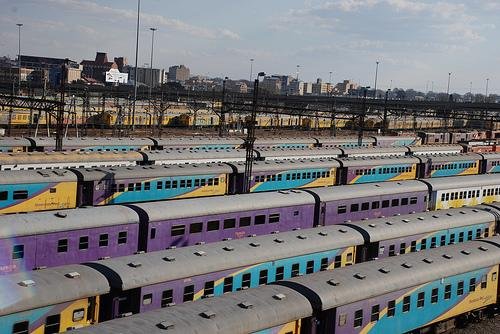Mention the type of the main vehicles captured in the image. The main vehicles in the image are passenger trains in different colors. What are some prominent architectural elements mentioned in the image description? Some architectural elements include tall buildings in the background, a horizontal bridge across the station, and black power lines over trains. In a multi-choice VQA task, list one possible question and four answer choices related to the image. D. Purple, gold, and blue Explain the arrangement of the trains and the overall setting of the image.  Multiple train coaches in various colors are on tracks, with some of them next to each other, outside in a railway station on a bright day with scattered clouds in the sky. What can be found in the background apart from the buildings and clouds? In the background, there are sparsely grown trees, light poles, and scattered city lighting posts. Briefly describe a scene where the image could be used in a product advertisement campaign. The image could be used to promote a new line of eco-friendly passenger trains with vibrant colors, emphasizing the modern and comfortable travel experience in a picturesque urban setting. Describe the condition of the sky in the image. The sky is blue with white clouds scattered in various positions. Identify the colors of the trains mentioned in the image descriptions. The train colors include purple, gold, blue, grey, and yellow. Describe some of the details mentioned about the train coaches. The train coaches have grey roofs, rectangular windows, and blue stripes on them. For a referential expression grounding task, describe where a white billboard can be found in the image. The white billboard is located next to some buildings, positioned at 105 units on the X-axis and 70 units on the Y-axis, with a width of 21 units and a height of 21 units. 